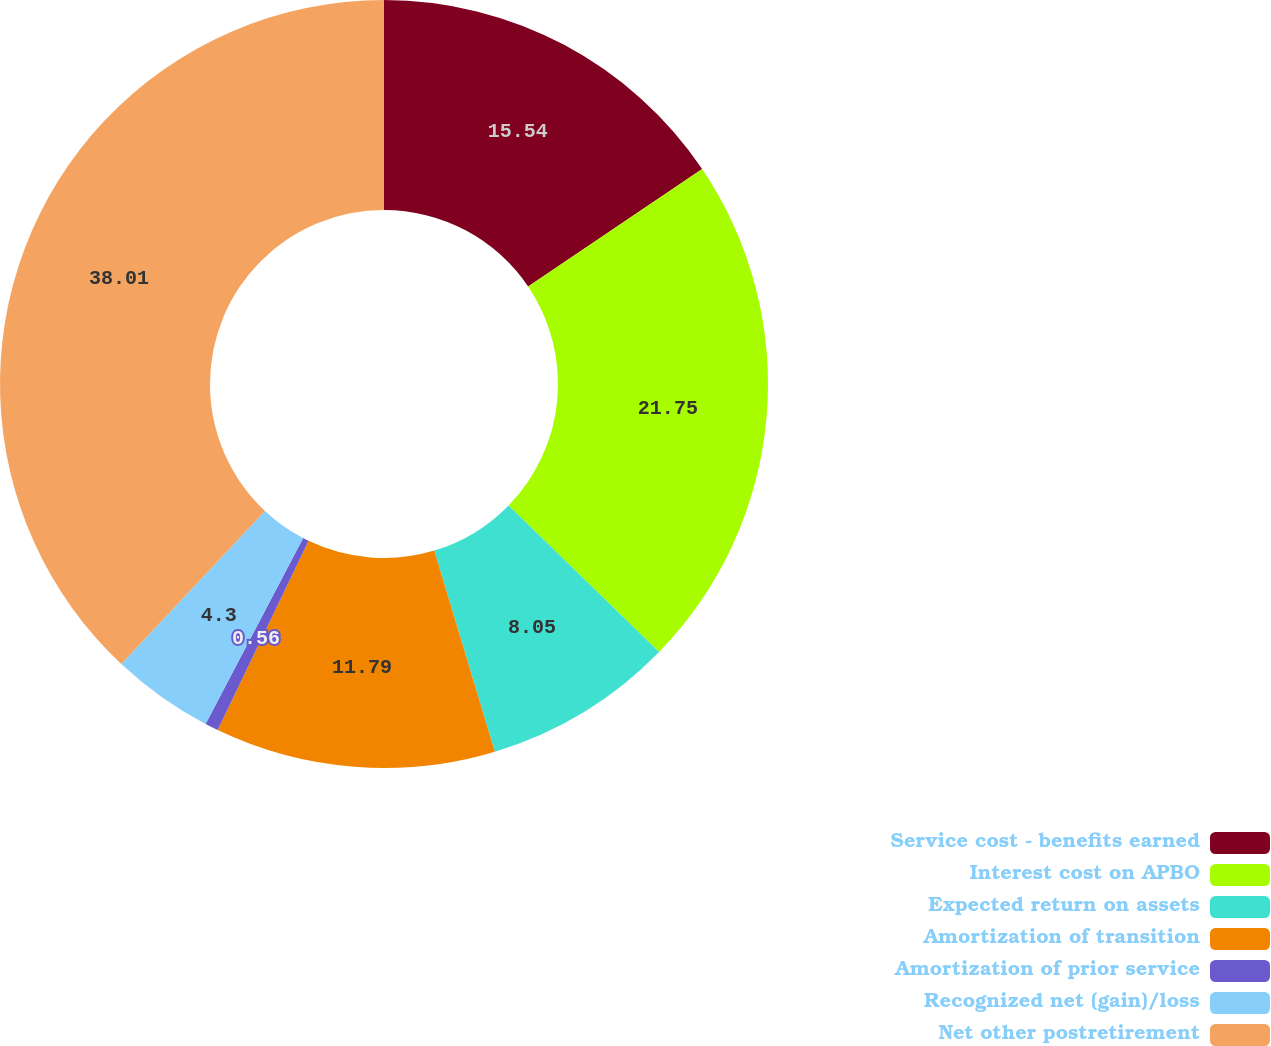Convert chart to OTSL. <chart><loc_0><loc_0><loc_500><loc_500><pie_chart><fcel>Service cost - benefits earned<fcel>Interest cost on APBO<fcel>Expected return on assets<fcel>Amortization of transition<fcel>Amortization of prior service<fcel>Recognized net (gain)/loss<fcel>Net other postretirement<nl><fcel>15.54%<fcel>21.75%<fcel>8.05%<fcel>11.79%<fcel>0.56%<fcel>4.3%<fcel>38.01%<nl></chart> 